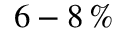Convert formula to latex. <formula><loc_0><loc_0><loc_500><loc_500>6 - 8 \, \%</formula> 